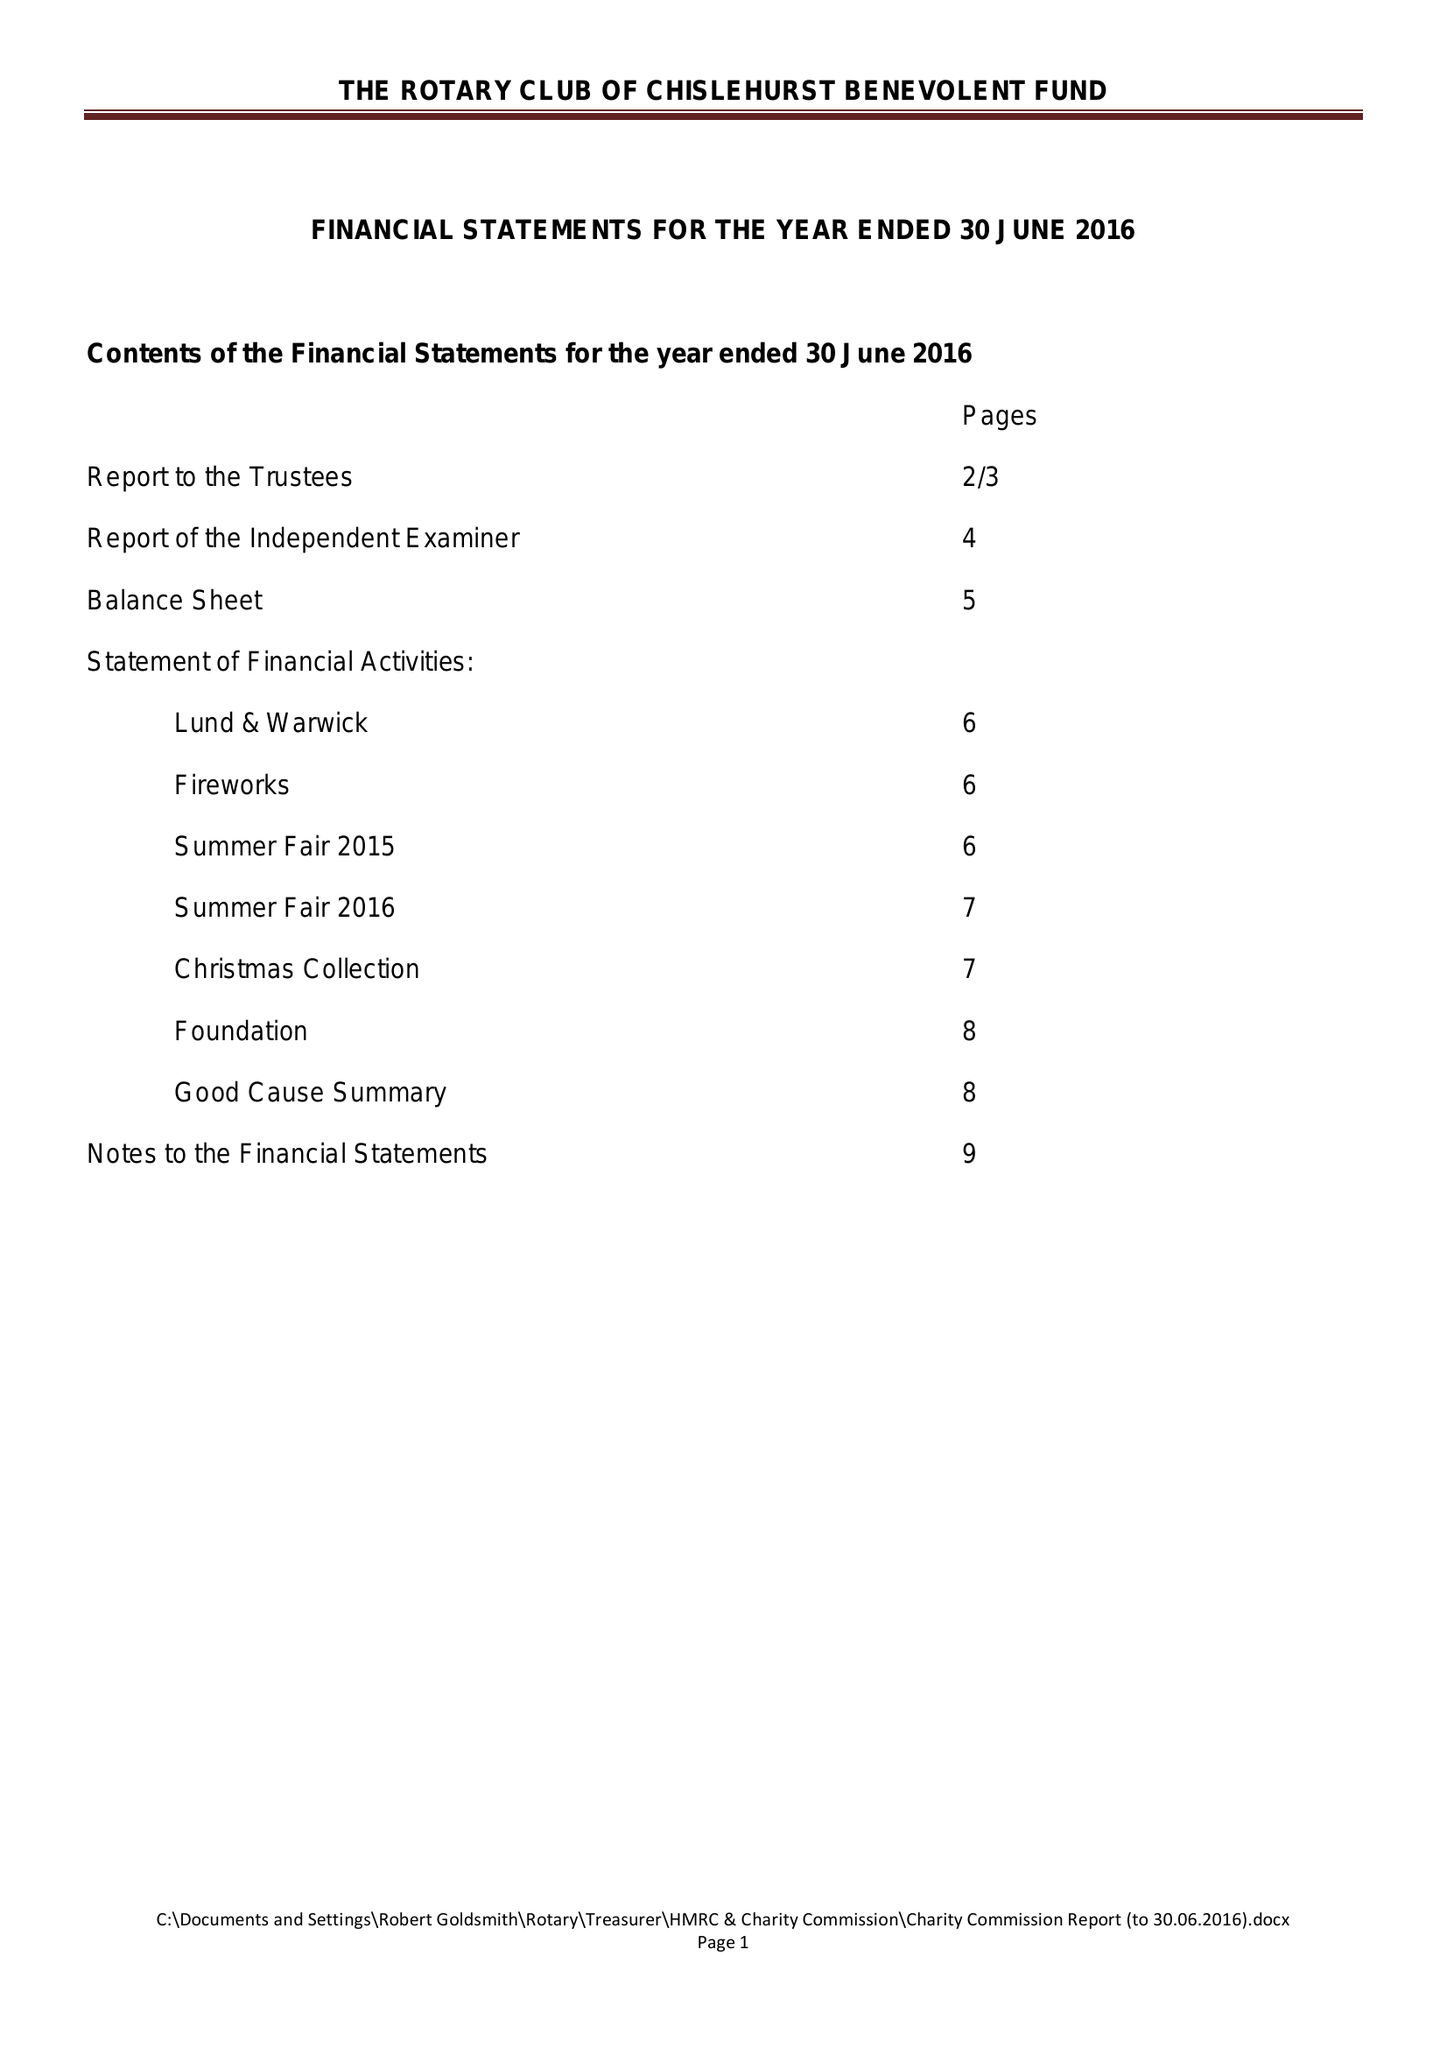What is the value for the address__post_town?
Answer the question using a single word or phrase. ORPINGTON 